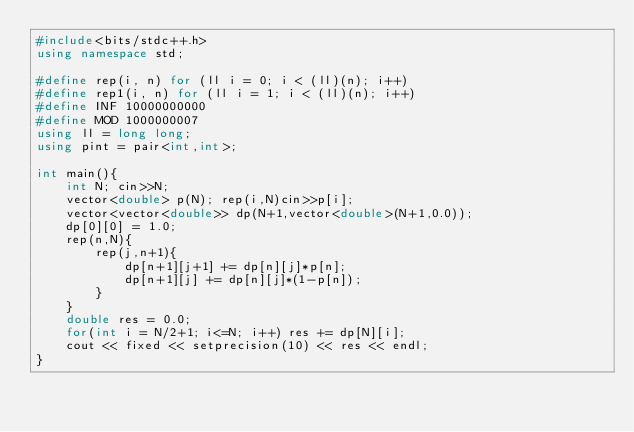<code> <loc_0><loc_0><loc_500><loc_500><_C++_>#include<bits/stdc++.h>
using namespace std;

#define rep(i, n) for (ll i = 0; i < (ll)(n); i++)
#define rep1(i, n) for (ll i = 1; i < (ll)(n); i++)
#define INF 10000000000
#define MOD 1000000007
using ll = long long;
using pint = pair<int,int>;

int main(){
    int N; cin>>N;
    vector<double> p(N); rep(i,N)cin>>p[i];
    vector<vector<double>> dp(N+1,vector<double>(N+1,0.0));
    dp[0][0] = 1.0;
    rep(n,N){
        rep(j,n+1){
            dp[n+1][j+1] += dp[n][j]*p[n];
            dp[n+1][j] += dp[n][j]*(1-p[n]);
        }
    }
    double res = 0.0;
    for(int i = N/2+1; i<=N; i++) res += dp[N][i];
    cout << fixed << setprecision(10) << res << endl;
}</code> 